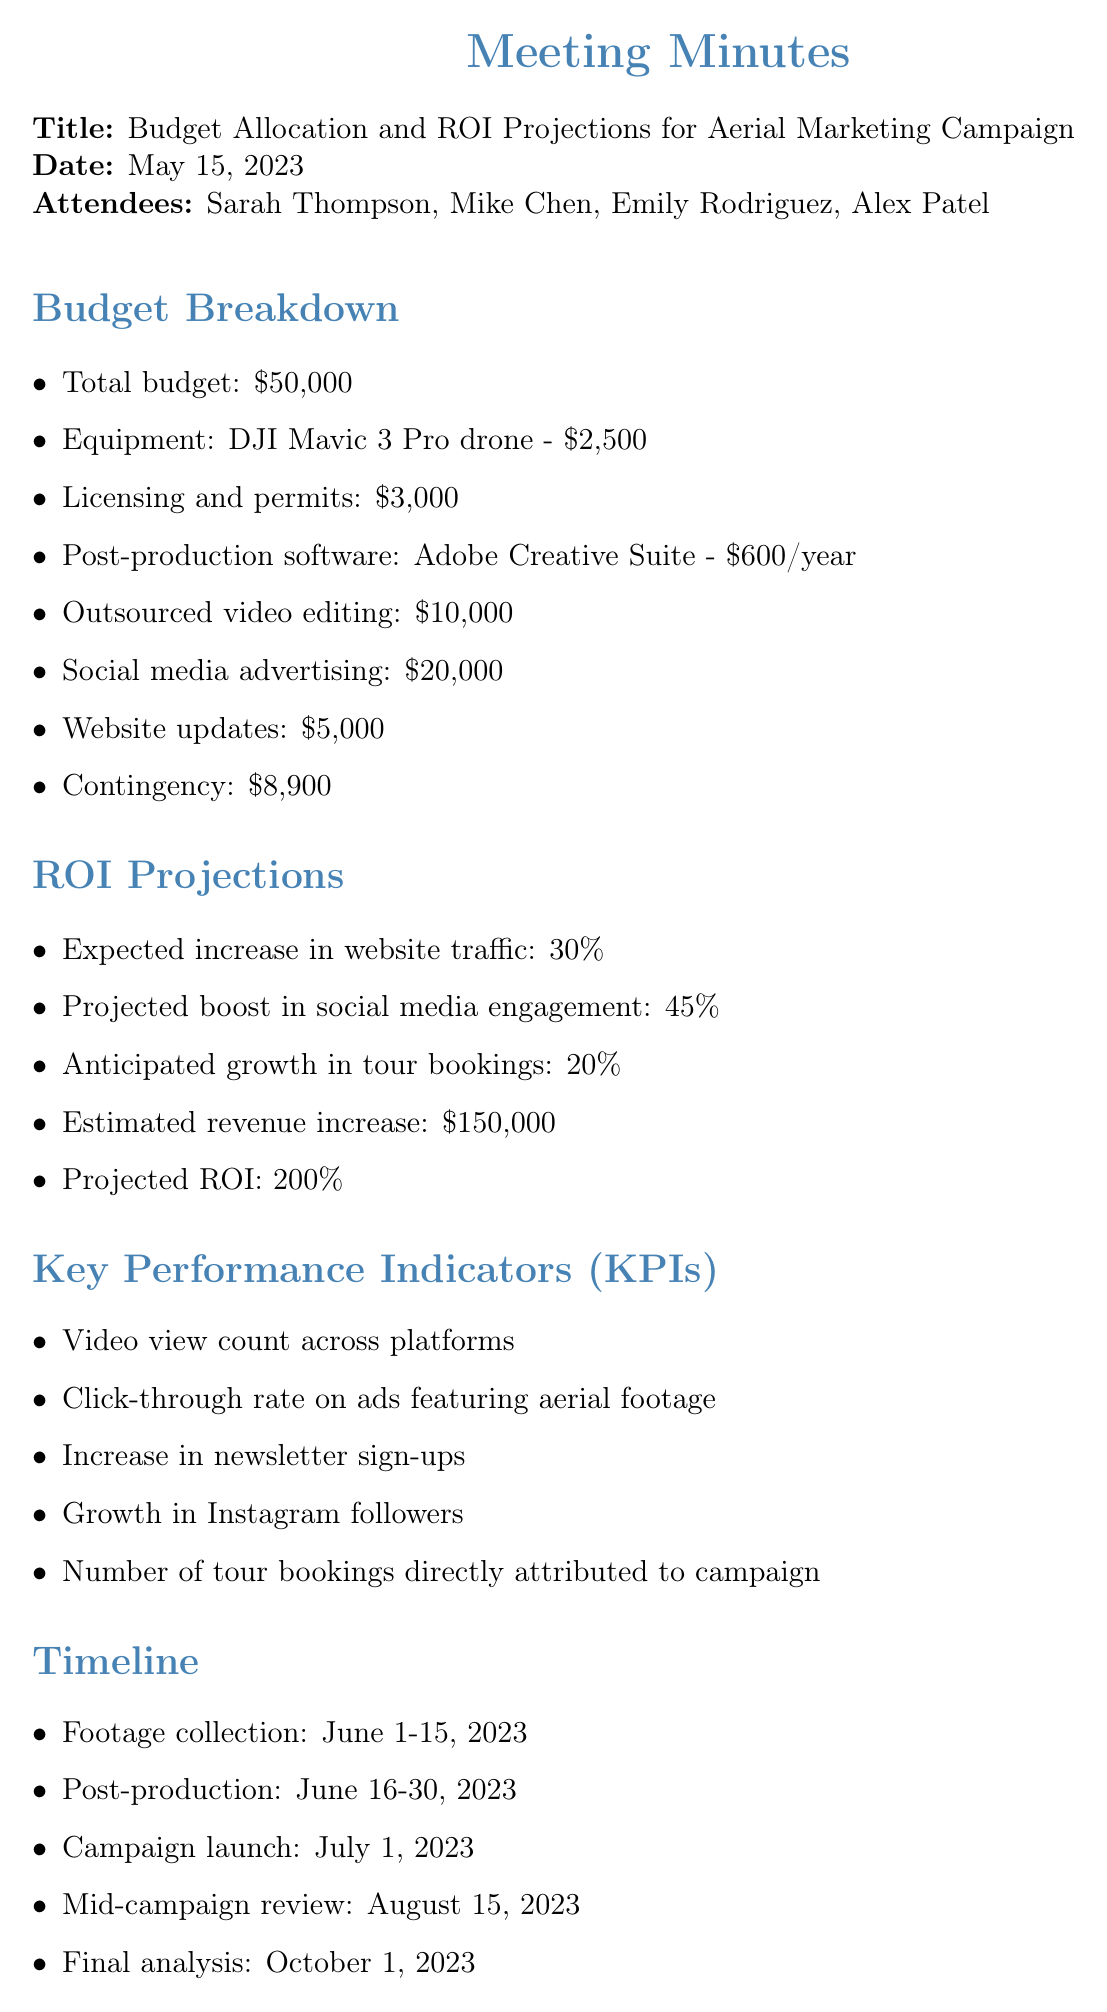What is the total budget? The total budget is listed as the main budget figure in the document.
Answer: $50,000 What is the cost of the DJI Mavic 3 Pro drone? The document specifies the cost of the drone as part of the budget breakdown.
Answer: $2,500 What is the expected increase in website traffic? This information can be found under the ROI Projections section, indicating the anticipated impact of the campaign.
Answer: 30% Who is responsible for obtaining necessary permits for drone flights? The action items section identifies who is tasked with specific responsibilities.
Answer: Mike What is the projected ROI for the campaign? The expected return on investment is highlighted in the ROI Projections section of the document.
Answer: 200% When is the campaign launch date? The timeline section provides key dates for the project, including when the campaign is set to launch.
Answer: July 1, 2023 What is one of the key performance indicators listed? The KPIs section lists various metrics to assess the campaign's success.
Answer: Video view count across platforms What is the budget allocated for social media advertising? The budget breakdown directly lists the amount allocated for social media initiatives.
Answer: $20,000 What is the timeline for post-production? This information is outlined in the timeline section, detailing when specific tasks will occur.
Answer: June 16-30, 2023 